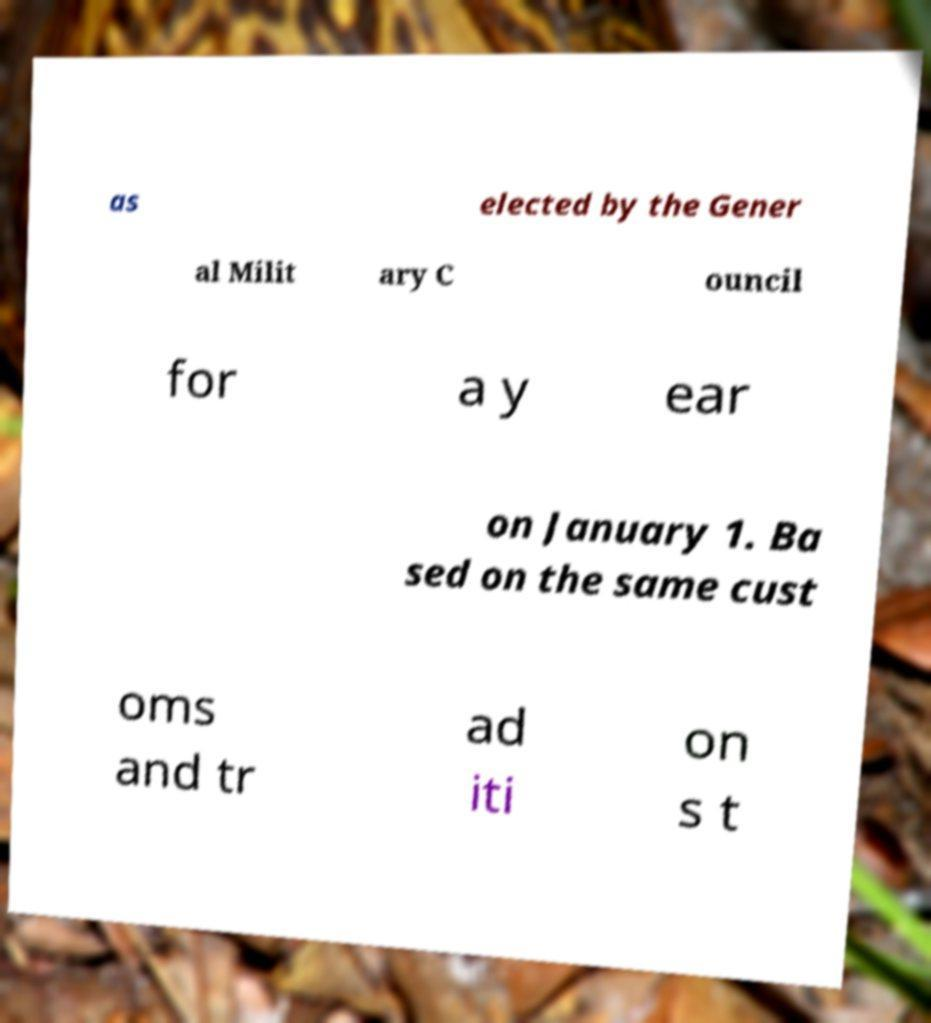Can you read and provide the text displayed in the image?This photo seems to have some interesting text. Can you extract and type it out for me? as elected by the Gener al Milit ary C ouncil for a y ear on January 1. Ba sed on the same cust oms and tr ad iti on s t 